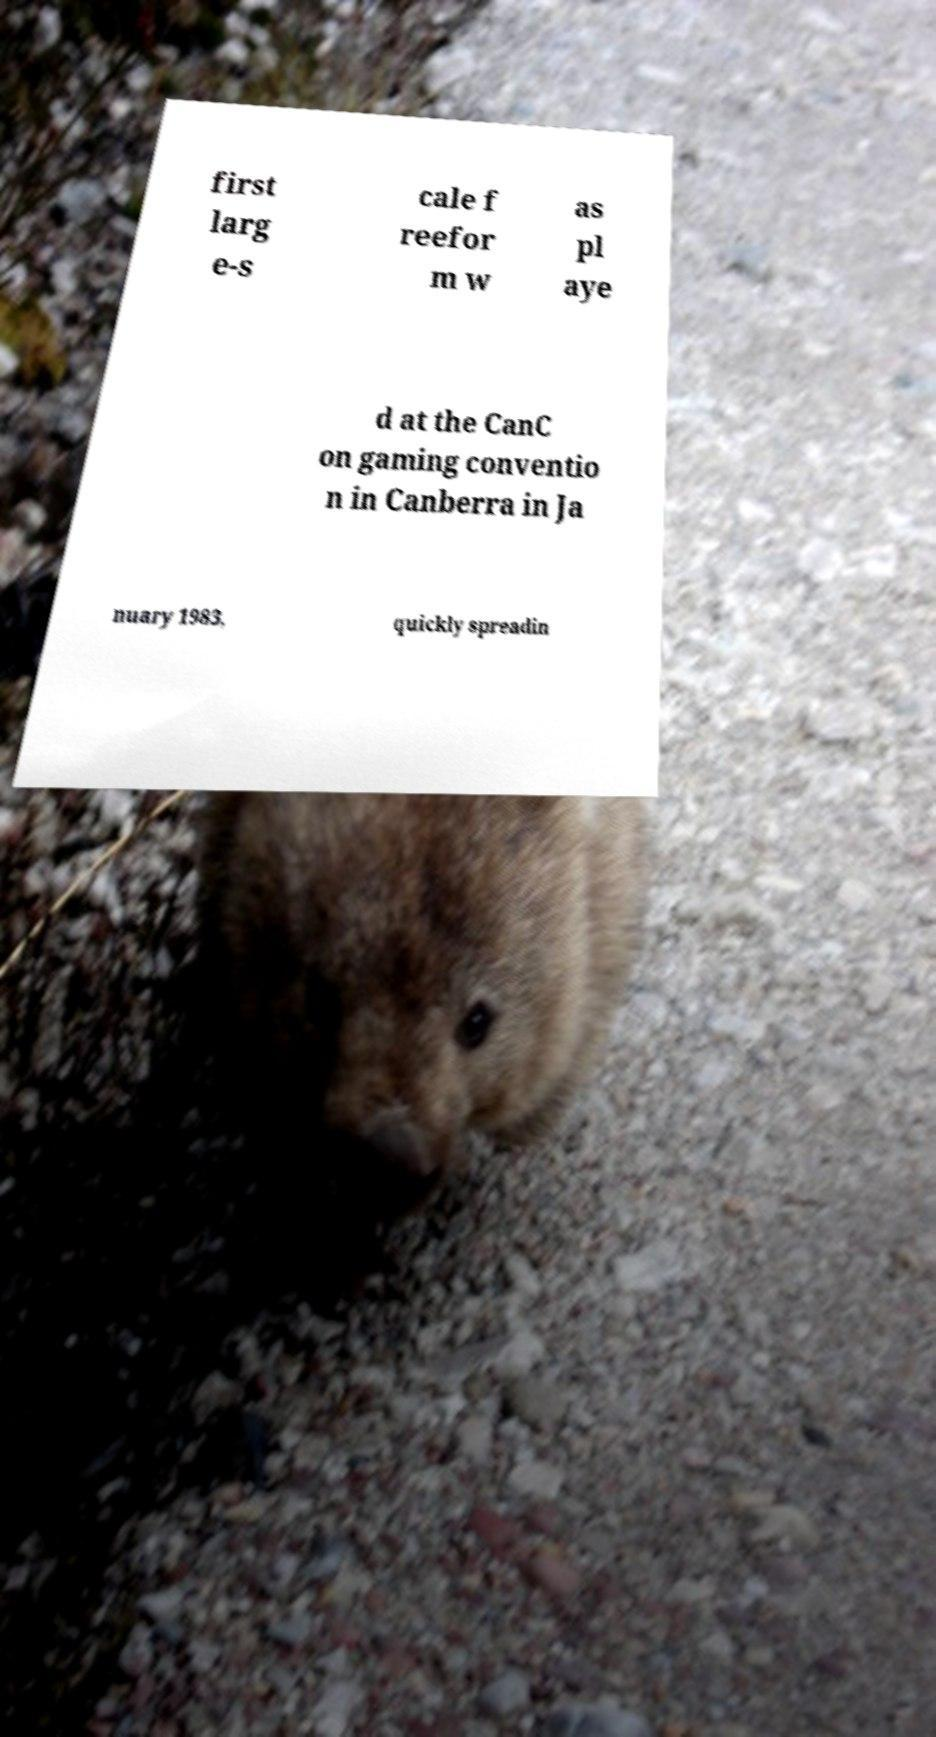For documentation purposes, I need the text within this image transcribed. Could you provide that? first larg e-s cale f reefor m w as pl aye d at the CanC on gaming conventio n in Canberra in Ja nuary 1983, quickly spreadin 